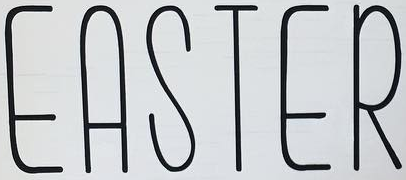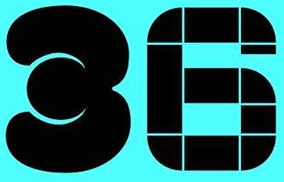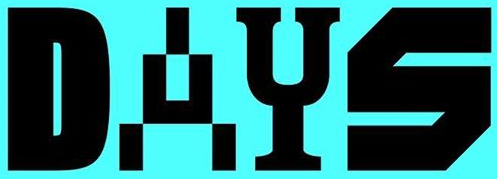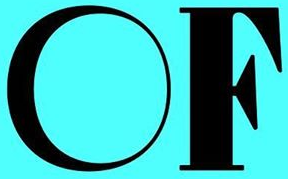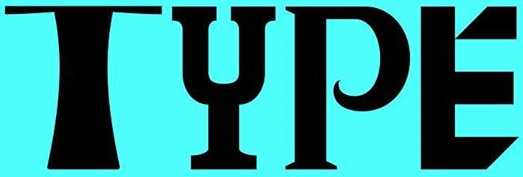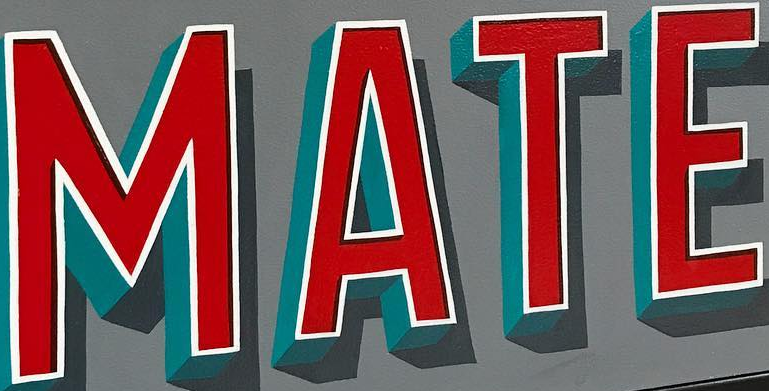What words can you see in these images in sequence, separated by a semicolon? EASTER; 36; DAYS; OF; TYPE; MATE 